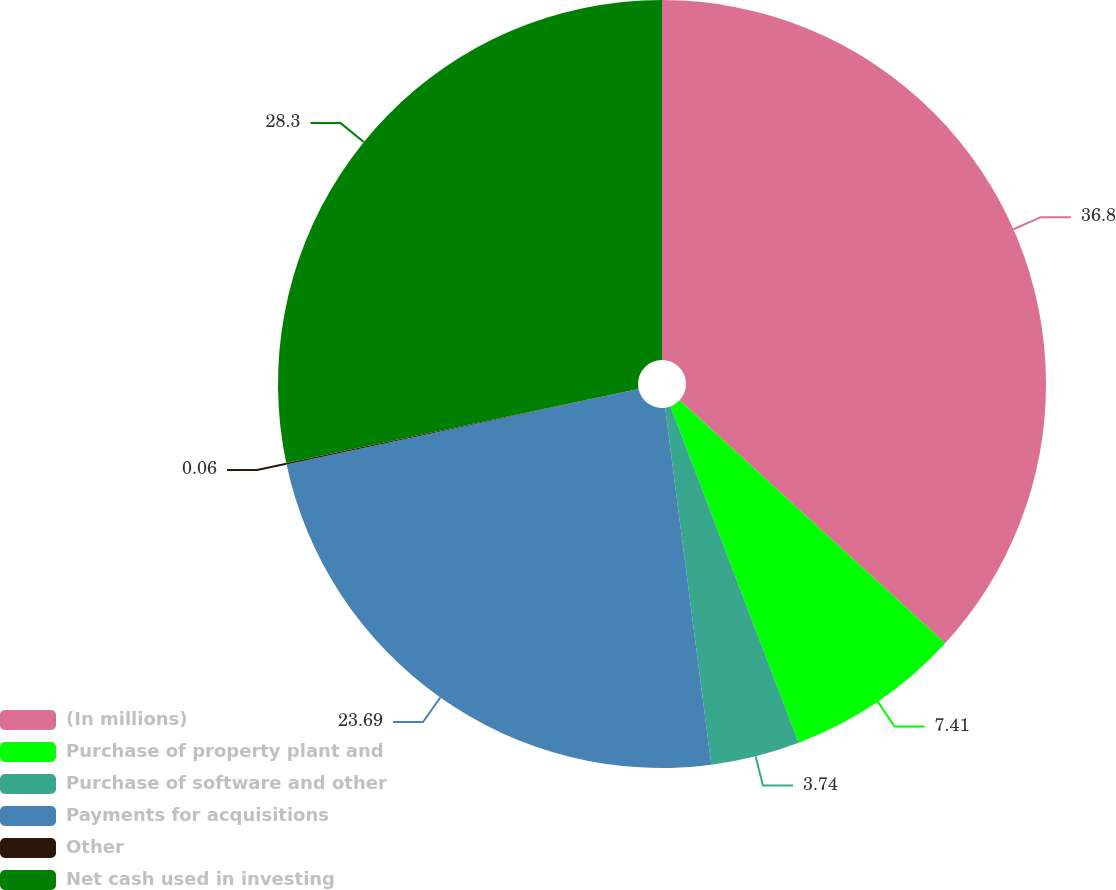Convert chart to OTSL. <chart><loc_0><loc_0><loc_500><loc_500><pie_chart><fcel>(In millions)<fcel>Purchase of property plant and<fcel>Purchase of software and other<fcel>Payments for acquisitions<fcel>Other<fcel>Net cash used in investing<nl><fcel>36.8%<fcel>7.41%<fcel>3.74%<fcel>23.69%<fcel>0.06%<fcel>28.3%<nl></chart> 